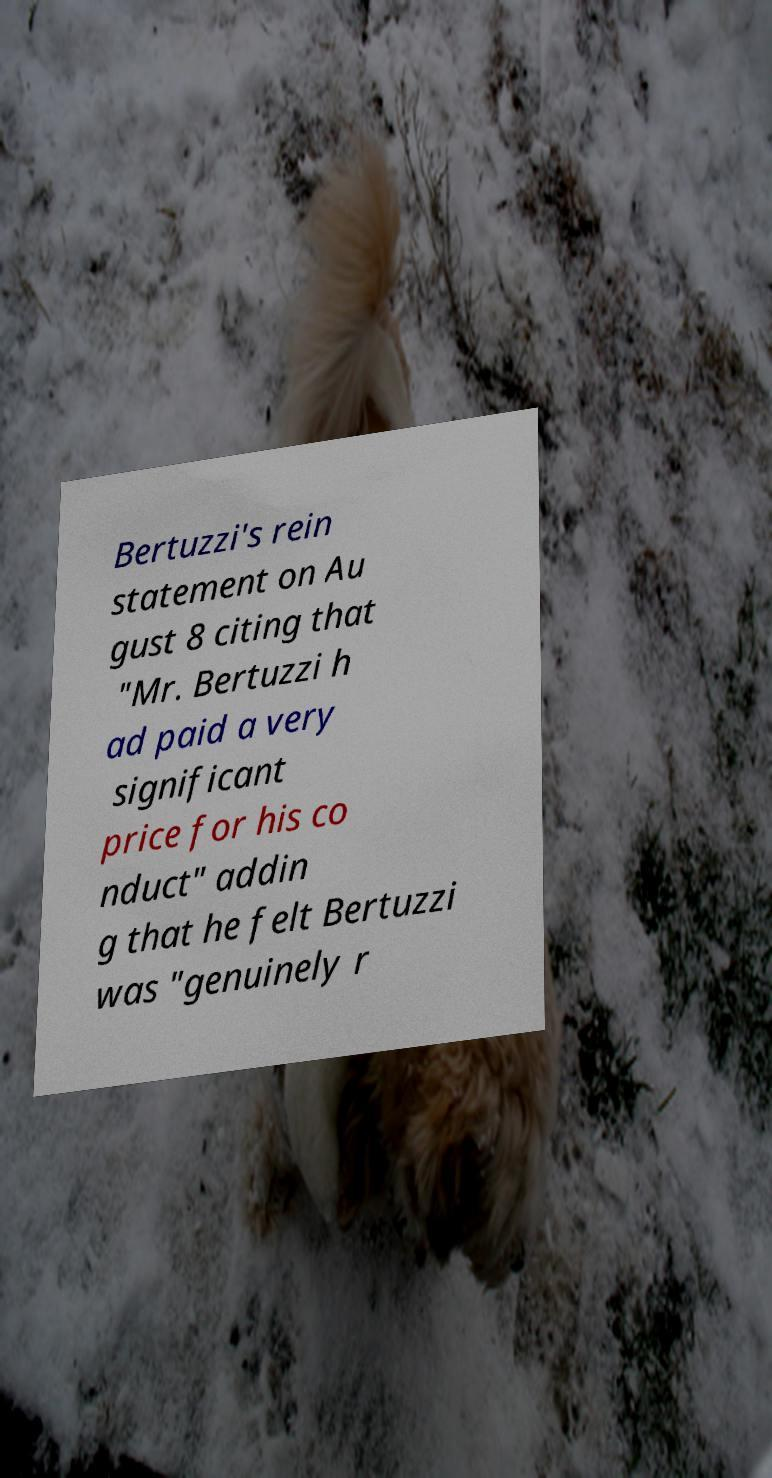For documentation purposes, I need the text within this image transcribed. Could you provide that? Bertuzzi's rein statement on Au gust 8 citing that "Mr. Bertuzzi h ad paid a very significant price for his co nduct" addin g that he felt Bertuzzi was "genuinely r 